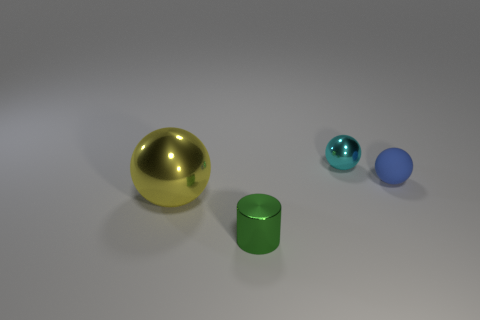Subtract all small cyan balls. How many balls are left? 2 Add 3 tiny blue objects. How many objects exist? 7 Subtract 1 balls. How many balls are left? 2 Subtract all spheres. How many objects are left? 1 Subtract all cyan balls. Subtract all cyan cylinders. How many balls are left? 2 Subtract all small cyan objects. Subtract all large yellow spheres. How many objects are left? 2 Add 1 tiny metallic cylinders. How many tiny metallic cylinders are left? 2 Add 3 small cyan metallic objects. How many small cyan metallic objects exist? 4 Subtract 1 green cylinders. How many objects are left? 3 